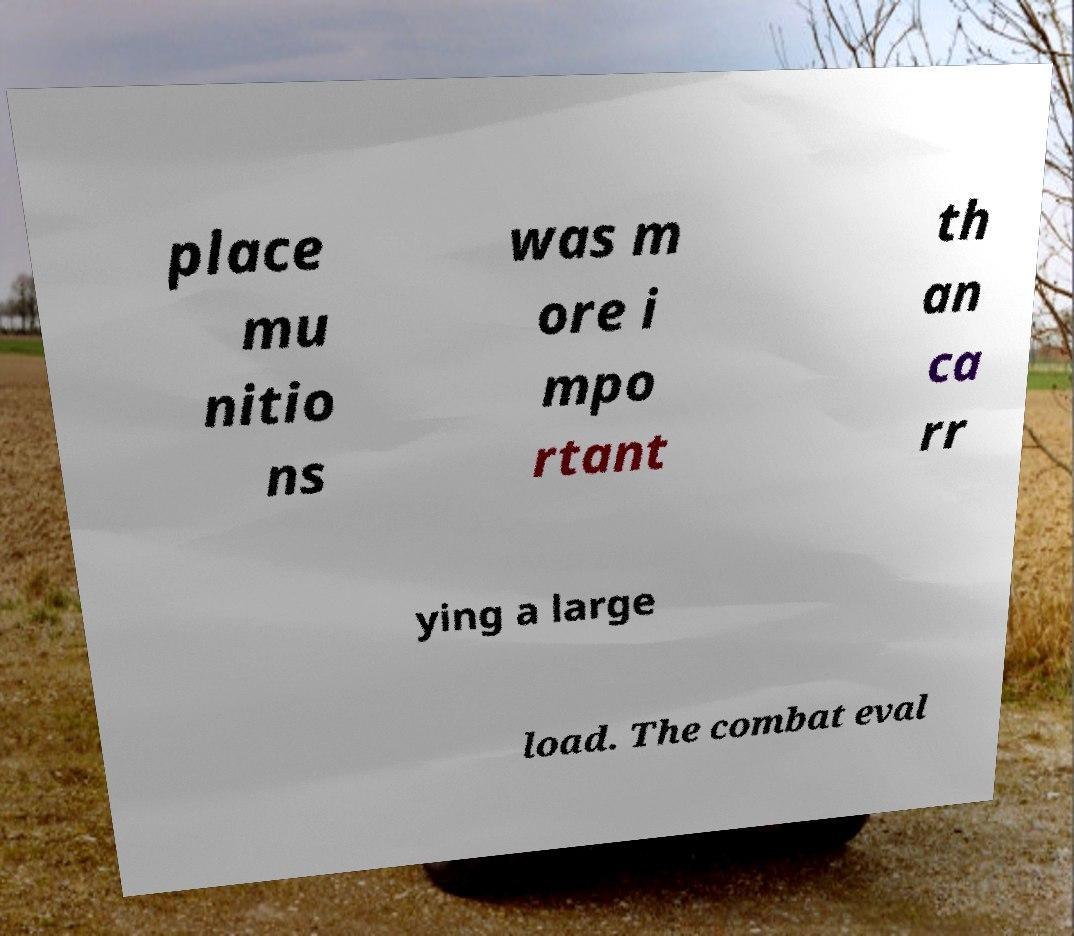For documentation purposes, I need the text within this image transcribed. Could you provide that? place mu nitio ns was m ore i mpo rtant th an ca rr ying a large load. The combat eval 